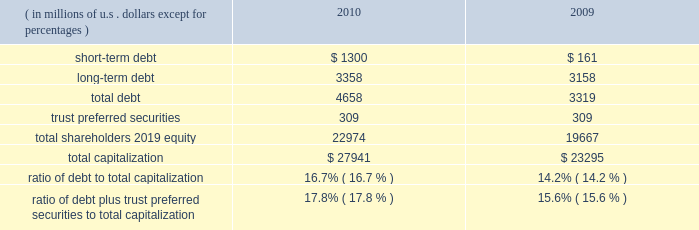Our consolidated net cash flows used for investing activities were $ 4.2 billion in 2010 , compared with $ 3.2 billion in 2009 .
Net investing activities for the indicated periods were related primarily to net purchases of fixed maturities and for 2010 included the acquisitions of rain and hail and jerneh insurance berhad .
Our consolidated net cash flows from financing activities were $ 732 million in 2010 , compared with net cash flows used for financing activities of $ 321 million in 2009 .
Net cash flows from/used for financing activities in 2010 and 2009 , included dividends paid on our common shares of $ 435 million and $ 388 million , respectively .
Net cash flows from financing activ- ities in 2010 , included net proceeds of $ 699 million from the issuance of long-term debt , $ 1 billion in reverse repurchase agreements , and $ 300 million in credit facility borrowings .
This was partially offset by repayment of $ 659 million in debt and share repurchases settled in 2010 of $ 235 million .
For 2009 , net cash flows used for financing activities included net pro- ceeds from the issuance of $ 500 million in long-term debt and the net repayment of debt and reverse repurchase agreements of $ 466 million .
Both internal and external forces influence our financial condition , results of operations , and cash flows .
Claim settle- ments , premium levels , and investment returns may be impacted by changing rates of inflation and other economic conditions .
In many cases , significant periods of time , ranging up to several years or more , may lapse between the occurrence of an insured loss , the reporting of the loss to us , and the settlement of the liability for that loss .
From time to time , we utilize reverse repurchase agreements as a low-cost alternative for short-term funding needs .
We use these instruments on a limited basis to address short-term cash timing differences without disrupting our investment portfolio holdings and settle the transactions with future operating cash flows .
At december 31 , 2010 , there were $ 1 billion in reverse repurchase agreements outstanding ( refer to short-term debt ) .
In addition to cash from operations , routine sales of investments , and financing arrangements , we have agreements with a bank provider which implemented two international multi-currency notional cash pooling programs to enhance cash management efficiency during periods of short-term timing mismatches between expected inflows and outflows of cash by currency .
In each program , participating ace entities establish deposit accounts in different currencies with the bank provider and each day the credit or debit balances in every account are notionally translated into a single currency ( u.s .
Dollars ) and then notionally pooled .
The bank extends overdraft credit to any participating ace entity as needed , provided that the overall notionally-pooled balance of all accounts in each pool at the end of each day is at least zero .
Actual cash balances are not physically converted and are not co-mingled between legal entities .
Ace entities may incur overdraft balances as a means to address short-term timing mismatches , and any overdraft balances incurred under this program by an ace entity would be guaranteed by ace limited ( up to $ 150 million in the aggregate ) .
Our revolving credit facility allows for same day drawings to fund a net pool overdraft should participating ace entities withdraw contributed funds from the pool .
Capital resources capital resources consist of funds deployed or available to be deployed to support our business operations .
The table summarizes the components of our capital resources at december 31 , 2010 , and 2009. .
Our ratios of debt to total capitalization and debt plus trust preferred securities to total capitalization have increased temporarily due to the increase in short-term debt , as discussed below .
We expect that these ratios will decline over the next six to nine months as we repay the short-term debt .
We believe our financial strength provides us with the flexibility and capacity to obtain available funds externally through debt or equity financing on both a short-term and long-term basis .
Our ability to access the capital markets is dependent on , among other things , market conditions and our perceived financial strength .
We have accessed both the debt and equity markets from time to time. .
What are the total assets reported in 2010? 
Computations: (4658 + 22974)
Answer: 27632.0. 